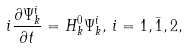<formula> <loc_0><loc_0><loc_500><loc_500>i \frac { \partial \Psi ^ { i } _ { k } } { \partial t } = H ^ { 0 } _ { k } \Psi ^ { i } _ { k } , \, i = 1 , \bar { 1 } , 2 ,</formula> 